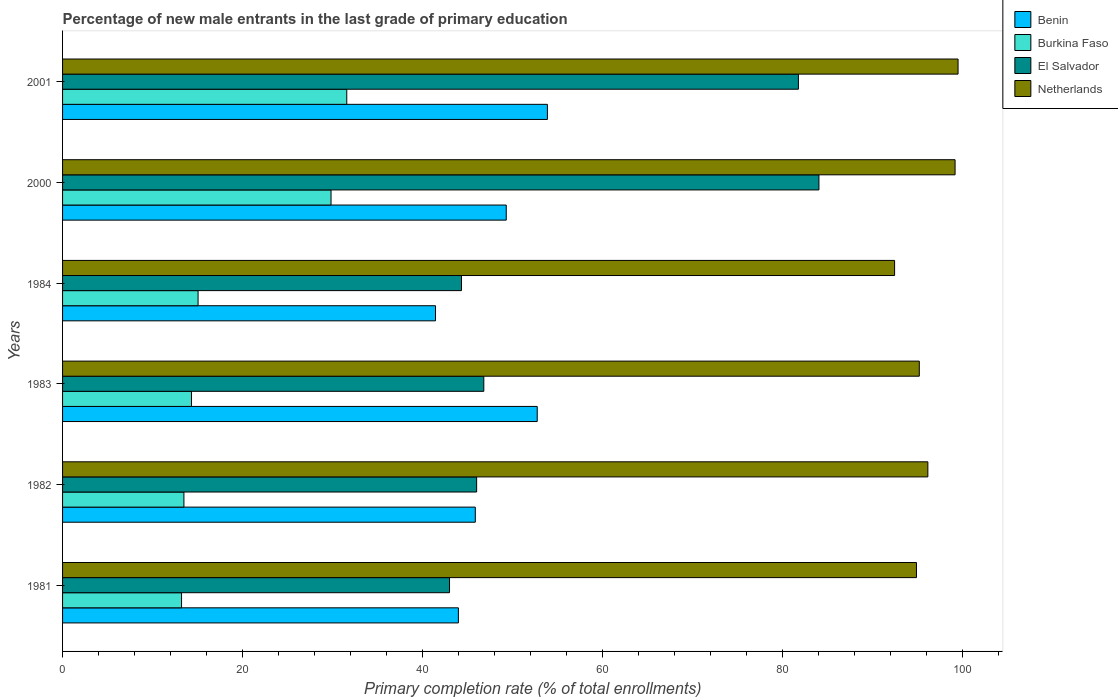How many different coloured bars are there?
Your answer should be compact. 4. How many groups of bars are there?
Offer a very short reply. 6. Are the number of bars per tick equal to the number of legend labels?
Your response must be concise. Yes. Are the number of bars on each tick of the Y-axis equal?
Your answer should be compact. Yes. How many bars are there on the 1st tick from the bottom?
Give a very brief answer. 4. In how many cases, is the number of bars for a given year not equal to the number of legend labels?
Your response must be concise. 0. What is the percentage of new male entrants in El Salvador in 1984?
Provide a short and direct response. 44.34. Across all years, what is the maximum percentage of new male entrants in Burkina Faso?
Provide a succinct answer. 31.59. Across all years, what is the minimum percentage of new male entrants in Netherlands?
Offer a very short reply. 92.48. In which year was the percentage of new male entrants in Netherlands maximum?
Ensure brevity in your answer.  2001. In which year was the percentage of new male entrants in El Salvador minimum?
Keep it short and to the point. 1981. What is the total percentage of new male entrants in Benin in the graph?
Your answer should be compact. 287.28. What is the difference between the percentage of new male entrants in Netherlands in 1983 and that in 2000?
Offer a very short reply. -3.98. What is the difference between the percentage of new male entrants in Benin in 1983 and the percentage of new male entrants in Burkina Faso in 1984?
Your answer should be very brief. 37.7. What is the average percentage of new male entrants in El Salvador per year?
Your answer should be compact. 57.67. In the year 1982, what is the difference between the percentage of new male entrants in El Salvador and percentage of new male entrants in Benin?
Offer a terse response. 0.15. What is the ratio of the percentage of new male entrants in Netherlands in 1984 to that in 2000?
Provide a short and direct response. 0.93. Is the percentage of new male entrants in El Salvador in 1984 less than that in 2000?
Offer a very short reply. Yes. What is the difference between the highest and the second highest percentage of new male entrants in Benin?
Offer a terse response. 1.13. What is the difference between the highest and the lowest percentage of new male entrants in Burkina Faso?
Provide a short and direct response. 18.36. Is it the case that in every year, the sum of the percentage of new male entrants in Netherlands and percentage of new male entrants in El Salvador is greater than the sum of percentage of new male entrants in Burkina Faso and percentage of new male entrants in Benin?
Offer a very short reply. Yes. What does the 2nd bar from the top in 2001 represents?
Your response must be concise. El Salvador. What does the 1st bar from the bottom in 1982 represents?
Your response must be concise. Benin. Is it the case that in every year, the sum of the percentage of new male entrants in El Salvador and percentage of new male entrants in Burkina Faso is greater than the percentage of new male entrants in Netherlands?
Provide a succinct answer. No. How many bars are there?
Make the answer very short. 24. How many years are there in the graph?
Your answer should be very brief. 6. What is the difference between two consecutive major ticks on the X-axis?
Keep it short and to the point. 20. Are the values on the major ticks of X-axis written in scientific E-notation?
Make the answer very short. No. How many legend labels are there?
Ensure brevity in your answer.  4. What is the title of the graph?
Your answer should be compact. Percentage of new male entrants in the last grade of primary education. What is the label or title of the X-axis?
Provide a succinct answer. Primary completion rate (% of total enrollments). What is the Primary completion rate (% of total enrollments) of Benin in 1981?
Your answer should be compact. 43.99. What is the Primary completion rate (% of total enrollments) in Burkina Faso in 1981?
Offer a terse response. 13.22. What is the Primary completion rate (% of total enrollments) of El Salvador in 1981?
Provide a succinct answer. 43.01. What is the Primary completion rate (% of total enrollments) of Netherlands in 1981?
Make the answer very short. 94.91. What is the Primary completion rate (% of total enrollments) of Benin in 1982?
Give a very brief answer. 45.87. What is the Primary completion rate (% of total enrollments) in Burkina Faso in 1982?
Make the answer very short. 13.49. What is the Primary completion rate (% of total enrollments) of El Salvador in 1982?
Ensure brevity in your answer.  46.02. What is the Primary completion rate (% of total enrollments) of Netherlands in 1982?
Give a very brief answer. 96.18. What is the Primary completion rate (% of total enrollments) in Benin in 1983?
Keep it short and to the point. 52.76. What is the Primary completion rate (% of total enrollments) of Burkina Faso in 1983?
Provide a succinct answer. 14.33. What is the Primary completion rate (% of total enrollments) of El Salvador in 1983?
Your response must be concise. 46.82. What is the Primary completion rate (% of total enrollments) in Netherlands in 1983?
Give a very brief answer. 95.22. What is the Primary completion rate (% of total enrollments) in Benin in 1984?
Your answer should be compact. 41.45. What is the Primary completion rate (% of total enrollments) in Burkina Faso in 1984?
Your response must be concise. 15.06. What is the Primary completion rate (% of total enrollments) in El Salvador in 1984?
Your answer should be compact. 44.34. What is the Primary completion rate (% of total enrollments) of Netherlands in 1984?
Your response must be concise. 92.48. What is the Primary completion rate (% of total enrollments) in Benin in 2000?
Offer a very short reply. 49.31. What is the Primary completion rate (% of total enrollments) in Burkina Faso in 2000?
Provide a short and direct response. 29.84. What is the Primary completion rate (% of total enrollments) of El Salvador in 2000?
Keep it short and to the point. 84.07. What is the Primary completion rate (% of total enrollments) in Netherlands in 2000?
Provide a succinct answer. 99.2. What is the Primary completion rate (% of total enrollments) of Benin in 2001?
Offer a terse response. 53.89. What is the Primary completion rate (% of total enrollments) in Burkina Faso in 2001?
Ensure brevity in your answer.  31.59. What is the Primary completion rate (% of total enrollments) in El Salvador in 2001?
Your answer should be compact. 81.79. What is the Primary completion rate (% of total enrollments) of Netherlands in 2001?
Offer a terse response. 99.53. Across all years, what is the maximum Primary completion rate (% of total enrollments) of Benin?
Give a very brief answer. 53.89. Across all years, what is the maximum Primary completion rate (% of total enrollments) in Burkina Faso?
Your response must be concise. 31.59. Across all years, what is the maximum Primary completion rate (% of total enrollments) in El Salvador?
Your answer should be very brief. 84.07. Across all years, what is the maximum Primary completion rate (% of total enrollments) of Netherlands?
Your answer should be very brief. 99.53. Across all years, what is the minimum Primary completion rate (% of total enrollments) of Benin?
Offer a very short reply. 41.45. Across all years, what is the minimum Primary completion rate (% of total enrollments) of Burkina Faso?
Offer a terse response. 13.22. Across all years, what is the minimum Primary completion rate (% of total enrollments) in El Salvador?
Keep it short and to the point. 43.01. Across all years, what is the minimum Primary completion rate (% of total enrollments) of Netherlands?
Offer a very short reply. 92.48. What is the total Primary completion rate (% of total enrollments) in Benin in the graph?
Offer a very short reply. 287.28. What is the total Primary completion rate (% of total enrollments) in Burkina Faso in the graph?
Make the answer very short. 117.53. What is the total Primary completion rate (% of total enrollments) in El Salvador in the graph?
Keep it short and to the point. 346.05. What is the total Primary completion rate (% of total enrollments) in Netherlands in the graph?
Your answer should be compact. 577.51. What is the difference between the Primary completion rate (% of total enrollments) in Benin in 1981 and that in 1982?
Provide a succinct answer. -1.88. What is the difference between the Primary completion rate (% of total enrollments) of Burkina Faso in 1981 and that in 1982?
Your answer should be very brief. -0.26. What is the difference between the Primary completion rate (% of total enrollments) in El Salvador in 1981 and that in 1982?
Give a very brief answer. -3.01. What is the difference between the Primary completion rate (% of total enrollments) in Netherlands in 1981 and that in 1982?
Your answer should be compact. -1.27. What is the difference between the Primary completion rate (% of total enrollments) in Benin in 1981 and that in 1983?
Provide a succinct answer. -8.76. What is the difference between the Primary completion rate (% of total enrollments) of Burkina Faso in 1981 and that in 1983?
Your response must be concise. -1.1. What is the difference between the Primary completion rate (% of total enrollments) of El Salvador in 1981 and that in 1983?
Offer a terse response. -3.81. What is the difference between the Primary completion rate (% of total enrollments) of Netherlands in 1981 and that in 1983?
Provide a succinct answer. -0.31. What is the difference between the Primary completion rate (% of total enrollments) in Benin in 1981 and that in 1984?
Offer a terse response. 2.54. What is the difference between the Primary completion rate (% of total enrollments) in Burkina Faso in 1981 and that in 1984?
Give a very brief answer. -1.84. What is the difference between the Primary completion rate (% of total enrollments) of El Salvador in 1981 and that in 1984?
Your answer should be compact. -1.33. What is the difference between the Primary completion rate (% of total enrollments) in Netherlands in 1981 and that in 1984?
Offer a very short reply. 2.43. What is the difference between the Primary completion rate (% of total enrollments) in Benin in 1981 and that in 2000?
Ensure brevity in your answer.  -5.32. What is the difference between the Primary completion rate (% of total enrollments) of Burkina Faso in 1981 and that in 2000?
Provide a succinct answer. -16.61. What is the difference between the Primary completion rate (% of total enrollments) of El Salvador in 1981 and that in 2000?
Provide a succinct answer. -41.06. What is the difference between the Primary completion rate (% of total enrollments) of Netherlands in 1981 and that in 2000?
Your answer should be very brief. -4.29. What is the difference between the Primary completion rate (% of total enrollments) of Benin in 1981 and that in 2001?
Provide a succinct answer. -9.89. What is the difference between the Primary completion rate (% of total enrollments) of Burkina Faso in 1981 and that in 2001?
Offer a terse response. -18.36. What is the difference between the Primary completion rate (% of total enrollments) of El Salvador in 1981 and that in 2001?
Ensure brevity in your answer.  -38.78. What is the difference between the Primary completion rate (% of total enrollments) in Netherlands in 1981 and that in 2001?
Ensure brevity in your answer.  -4.62. What is the difference between the Primary completion rate (% of total enrollments) of Benin in 1982 and that in 1983?
Keep it short and to the point. -6.88. What is the difference between the Primary completion rate (% of total enrollments) of Burkina Faso in 1982 and that in 1983?
Your answer should be very brief. -0.84. What is the difference between the Primary completion rate (% of total enrollments) in El Salvador in 1982 and that in 1983?
Keep it short and to the point. -0.8. What is the difference between the Primary completion rate (% of total enrollments) of Netherlands in 1982 and that in 1983?
Offer a very short reply. 0.95. What is the difference between the Primary completion rate (% of total enrollments) of Benin in 1982 and that in 1984?
Offer a terse response. 4.42. What is the difference between the Primary completion rate (% of total enrollments) of Burkina Faso in 1982 and that in 1984?
Provide a short and direct response. -1.57. What is the difference between the Primary completion rate (% of total enrollments) of El Salvador in 1982 and that in 1984?
Your response must be concise. 1.68. What is the difference between the Primary completion rate (% of total enrollments) of Netherlands in 1982 and that in 1984?
Offer a very short reply. 3.7. What is the difference between the Primary completion rate (% of total enrollments) of Benin in 1982 and that in 2000?
Your response must be concise. -3.44. What is the difference between the Primary completion rate (% of total enrollments) in Burkina Faso in 1982 and that in 2000?
Your response must be concise. -16.35. What is the difference between the Primary completion rate (% of total enrollments) in El Salvador in 1982 and that in 2000?
Offer a very short reply. -38.05. What is the difference between the Primary completion rate (% of total enrollments) of Netherlands in 1982 and that in 2000?
Provide a short and direct response. -3.02. What is the difference between the Primary completion rate (% of total enrollments) of Benin in 1982 and that in 2001?
Provide a short and direct response. -8.01. What is the difference between the Primary completion rate (% of total enrollments) in Burkina Faso in 1982 and that in 2001?
Ensure brevity in your answer.  -18.1. What is the difference between the Primary completion rate (% of total enrollments) of El Salvador in 1982 and that in 2001?
Your response must be concise. -35.76. What is the difference between the Primary completion rate (% of total enrollments) in Netherlands in 1982 and that in 2001?
Offer a very short reply. -3.36. What is the difference between the Primary completion rate (% of total enrollments) of Benin in 1983 and that in 1984?
Give a very brief answer. 11.31. What is the difference between the Primary completion rate (% of total enrollments) of Burkina Faso in 1983 and that in 1984?
Your answer should be compact. -0.73. What is the difference between the Primary completion rate (% of total enrollments) in El Salvador in 1983 and that in 1984?
Offer a terse response. 2.48. What is the difference between the Primary completion rate (% of total enrollments) of Netherlands in 1983 and that in 1984?
Provide a succinct answer. 2.75. What is the difference between the Primary completion rate (% of total enrollments) of Benin in 1983 and that in 2000?
Provide a succinct answer. 3.44. What is the difference between the Primary completion rate (% of total enrollments) in Burkina Faso in 1983 and that in 2000?
Offer a very short reply. -15.51. What is the difference between the Primary completion rate (% of total enrollments) of El Salvador in 1983 and that in 2000?
Ensure brevity in your answer.  -37.25. What is the difference between the Primary completion rate (% of total enrollments) in Netherlands in 1983 and that in 2000?
Your response must be concise. -3.98. What is the difference between the Primary completion rate (% of total enrollments) of Benin in 1983 and that in 2001?
Your answer should be compact. -1.13. What is the difference between the Primary completion rate (% of total enrollments) of Burkina Faso in 1983 and that in 2001?
Your response must be concise. -17.26. What is the difference between the Primary completion rate (% of total enrollments) in El Salvador in 1983 and that in 2001?
Ensure brevity in your answer.  -34.96. What is the difference between the Primary completion rate (% of total enrollments) of Netherlands in 1983 and that in 2001?
Offer a terse response. -4.31. What is the difference between the Primary completion rate (% of total enrollments) of Benin in 1984 and that in 2000?
Offer a terse response. -7.86. What is the difference between the Primary completion rate (% of total enrollments) of Burkina Faso in 1984 and that in 2000?
Provide a succinct answer. -14.78. What is the difference between the Primary completion rate (% of total enrollments) of El Salvador in 1984 and that in 2000?
Offer a very short reply. -39.73. What is the difference between the Primary completion rate (% of total enrollments) of Netherlands in 1984 and that in 2000?
Your answer should be very brief. -6.72. What is the difference between the Primary completion rate (% of total enrollments) in Benin in 1984 and that in 2001?
Offer a terse response. -12.44. What is the difference between the Primary completion rate (% of total enrollments) of Burkina Faso in 1984 and that in 2001?
Offer a very short reply. -16.53. What is the difference between the Primary completion rate (% of total enrollments) in El Salvador in 1984 and that in 2001?
Make the answer very short. -37.44. What is the difference between the Primary completion rate (% of total enrollments) of Netherlands in 1984 and that in 2001?
Offer a terse response. -7.05. What is the difference between the Primary completion rate (% of total enrollments) of Benin in 2000 and that in 2001?
Offer a very short reply. -4.57. What is the difference between the Primary completion rate (% of total enrollments) of Burkina Faso in 2000 and that in 2001?
Offer a terse response. -1.75. What is the difference between the Primary completion rate (% of total enrollments) of El Salvador in 2000 and that in 2001?
Keep it short and to the point. 2.28. What is the difference between the Primary completion rate (% of total enrollments) of Netherlands in 2000 and that in 2001?
Your answer should be very brief. -0.33. What is the difference between the Primary completion rate (% of total enrollments) of Benin in 1981 and the Primary completion rate (% of total enrollments) of Burkina Faso in 1982?
Your answer should be very brief. 30.51. What is the difference between the Primary completion rate (% of total enrollments) of Benin in 1981 and the Primary completion rate (% of total enrollments) of El Salvador in 1982?
Ensure brevity in your answer.  -2.03. What is the difference between the Primary completion rate (% of total enrollments) of Benin in 1981 and the Primary completion rate (% of total enrollments) of Netherlands in 1982?
Provide a succinct answer. -52.18. What is the difference between the Primary completion rate (% of total enrollments) in Burkina Faso in 1981 and the Primary completion rate (% of total enrollments) in El Salvador in 1982?
Your answer should be compact. -32.8. What is the difference between the Primary completion rate (% of total enrollments) of Burkina Faso in 1981 and the Primary completion rate (% of total enrollments) of Netherlands in 1982?
Make the answer very short. -82.95. What is the difference between the Primary completion rate (% of total enrollments) of El Salvador in 1981 and the Primary completion rate (% of total enrollments) of Netherlands in 1982?
Provide a short and direct response. -53.17. What is the difference between the Primary completion rate (% of total enrollments) of Benin in 1981 and the Primary completion rate (% of total enrollments) of Burkina Faso in 1983?
Offer a terse response. 29.67. What is the difference between the Primary completion rate (% of total enrollments) of Benin in 1981 and the Primary completion rate (% of total enrollments) of El Salvador in 1983?
Ensure brevity in your answer.  -2.83. What is the difference between the Primary completion rate (% of total enrollments) of Benin in 1981 and the Primary completion rate (% of total enrollments) of Netherlands in 1983?
Give a very brief answer. -51.23. What is the difference between the Primary completion rate (% of total enrollments) in Burkina Faso in 1981 and the Primary completion rate (% of total enrollments) in El Salvador in 1983?
Provide a succinct answer. -33.6. What is the difference between the Primary completion rate (% of total enrollments) in Burkina Faso in 1981 and the Primary completion rate (% of total enrollments) in Netherlands in 1983?
Keep it short and to the point. -82. What is the difference between the Primary completion rate (% of total enrollments) in El Salvador in 1981 and the Primary completion rate (% of total enrollments) in Netherlands in 1983?
Give a very brief answer. -52.21. What is the difference between the Primary completion rate (% of total enrollments) in Benin in 1981 and the Primary completion rate (% of total enrollments) in Burkina Faso in 1984?
Offer a terse response. 28.93. What is the difference between the Primary completion rate (% of total enrollments) in Benin in 1981 and the Primary completion rate (% of total enrollments) in El Salvador in 1984?
Offer a very short reply. -0.35. What is the difference between the Primary completion rate (% of total enrollments) in Benin in 1981 and the Primary completion rate (% of total enrollments) in Netherlands in 1984?
Offer a terse response. -48.48. What is the difference between the Primary completion rate (% of total enrollments) in Burkina Faso in 1981 and the Primary completion rate (% of total enrollments) in El Salvador in 1984?
Offer a terse response. -31.12. What is the difference between the Primary completion rate (% of total enrollments) of Burkina Faso in 1981 and the Primary completion rate (% of total enrollments) of Netherlands in 1984?
Keep it short and to the point. -79.25. What is the difference between the Primary completion rate (% of total enrollments) of El Salvador in 1981 and the Primary completion rate (% of total enrollments) of Netherlands in 1984?
Offer a terse response. -49.47. What is the difference between the Primary completion rate (% of total enrollments) in Benin in 1981 and the Primary completion rate (% of total enrollments) in Burkina Faso in 2000?
Keep it short and to the point. 14.16. What is the difference between the Primary completion rate (% of total enrollments) of Benin in 1981 and the Primary completion rate (% of total enrollments) of El Salvador in 2000?
Your answer should be very brief. -40.07. What is the difference between the Primary completion rate (% of total enrollments) of Benin in 1981 and the Primary completion rate (% of total enrollments) of Netherlands in 2000?
Ensure brevity in your answer.  -55.21. What is the difference between the Primary completion rate (% of total enrollments) of Burkina Faso in 1981 and the Primary completion rate (% of total enrollments) of El Salvador in 2000?
Offer a terse response. -70.84. What is the difference between the Primary completion rate (% of total enrollments) in Burkina Faso in 1981 and the Primary completion rate (% of total enrollments) in Netherlands in 2000?
Your answer should be compact. -85.97. What is the difference between the Primary completion rate (% of total enrollments) of El Salvador in 1981 and the Primary completion rate (% of total enrollments) of Netherlands in 2000?
Provide a succinct answer. -56.19. What is the difference between the Primary completion rate (% of total enrollments) of Benin in 1981 and the Primary completion rate (% of total enrollments) of Burkina Faso in 2001?
Provide a short and direct response. 12.41. What is the difference between the Primary completion rate (% of total enrollments) in Benin in 1981 and the Primary completion rate (% of total enrollments) in El Salvador in 2001?
Your answer should be compact. -37.79. What is the difference between the Primary completion rate (% of total enrollments) of Benin in 1981 and the Primary completion rate (% of total enrollments) of Netherlands in 2001?
Provide a succinct answer. -55.54. What is the difference between the Primary completion rate (% of total enrollments) of Burkina Faso in 1981 and the Primary completion rate (% of total enrollments) of El Salvador in 2001?
Provide a short and direct response. -68.56. What is the difference between the Primary completion rate (% of total enrollments) in Burkina Faso in 1981 and the Primary completion rate (% of total enrollments) in Netherlands in 2001?
Make the answer very short. -86.31. What is the difference between the Primary completion rate (% of total enrollments) of El Salvador in 1981 and the Primary completion rate (% of total enrollments) of Netherlands in 2001?
Provide a succinct answer. -56.52. What is the difference between the Primary completion rate (% of total enrollments) of Benin in 1982 and the Primary completion rate (% of total enrollments) of Burkina Faso in 1983?
Give a very brief answer. 31.55. What is the difference between the Primary completion rate (% of total enrollments) in Benin in 1982 and the Primary completion rate (% of total enrollments) in El Salvador in 1983?
Keep it short and to the point. -0.95. What is the difference between the Primary completion rate (% of total enrollments) of Benin in 1982 and the Primary completion rate (% of total enrollments) of Netherlands in 1983?
Provide a short and direct response. -49.35. What is the difference between the Primary completion rate (% of total enrollments) of Burkina Faso in 1982 and the Primary completion rate (% of total enrollments) of El Salvador in 1983?
Ensure brevity in your answer.  -33.33. What is the difference between the Primary completion rate (% of total enrollments) of Burkina Faso in 1982 and the Primary completion rate (% of total enrollments) of Netherlands in 1983?
Offer a very short reply. -81.73. What is the difference between the Primary completion rate (% of total enrollments) of El Salvador in 1982 and the Primary completion rate (% of total enrollments) of Netherlands in 1983?
Provide a succinct answer. -49.2. What is the difference between the Primary completion rate (% of total enrollments) of Benin in 1982 and the Primary completion rate (% of total enrollments) of Burkina Faso in 1984?
Give a very brief answer. 30.81. What is the difference between the Primary completion rate (% of total enrollments) of Benin in 1982 and the Primary completion rate (% of total enrollments) of El Salvador in 1984?
Your answer should be compact. 1.53. What is the difference between the Primary completion rate (% of total enrollments) in Benin in 1982 and the Primary completion rate (% of total enrollments) in Netherlands in 1984?
Offer a very short reply. -46.6. What is the difference between the Primary completion rate (% of total enrollments) of Burkina Faso in 1982 and the Primary completion rate (% of total enrollments) of El Salvador in 1984?
Your answer should be very brief. -30.85. What is the difference between the Primary completion rate (% of total enrollments) of Burkina Faso in 1982 and the Primary completion rate (% of total enrollments) of Netherlands in 1984?
Your response must be concise. -78.99. What is the difference between the Primary completion rate (% of total enrollments) in El Salvador in 1982 and the Primary completion rate (% of total enrollments) in Netherlands in 1984?
Make the answer very short. -46.45. What is the difference between the Primary completion rate (% of total enrollments) of Benin in 1982 and the Primary completion rate (% of total enrollments) of Burkina Faso in 2000?
Provide a short and direct response. 16.03. What is the difference between the Primary completion rate (% of total enrollments) in Benin in 1982 and the Primary completion rate (% of total enrollments) in El Salvador in 2000?
Give a very brief answer. -38.19. What is the difference between the Primary completion rate (% of total enrollments) in Benin in 1982 and the Primary completion rate (% of total enrollments) in Netherlands in 2000?
Make the answer very short. -53.33. What is the difference between the Primary completion rate (% of total enrollments) in Burkina Faso in 1982 and the Primary completion rate (% of total enrollments) in El Salvador in 2000?
Ensure brevity in your answer.  -70.58. What is the difference between the Primary completion rate (% of total enrollments) of Burkina Faso in 1982 and the Primary completion rate (% of total enrollments) of Netherlands in 2000?
Keep it short and to the point. -85.71. What is the difference between the Primary completion rate (% of total enrollments) of El Salvador in 1982 and the Primary completion rate (% of total enrollments) of Netherlands in 2000?
Offer a very short reply. -53.18. What is the difference between the Primary completion rate (% of total enrollments) of Benin in 1982 and the Primary completion rate (% of total enrollments) of Burkina Faso in 2001?
Your response must be concise. 14.28. What is the difference between the Primary completion rate (% of total enrollments) in Benin in 1982 and the Primary completion rate (% of total enrollments) in El Salvador in 2001?
Provide a succinct answer. -35.91. What is the difference between the Primary completion rate (% of total enrollments) in Benin in 1982 and the Primary completion rate (% of total enrollments) in Netherlands in 2001?
Offer a terse response. -53.66. What is the difference between the Primary completion rate (% of total enrollments) in Burkina Faso in 1982 and the Primary completion rate (% of total enrollments) in El Salvador in 2001?
Give a very brief answer. -68.3. What is the difference between the Primary completion rate (% of total enrollments) in Burkina Faso in 1982 and the Primary completion rate (% of total enrollments) in Netherlands in 2001?
Your answer should be very brief. -86.04. What is the difference between the Primary completion rate (% of total enrollments) in El Salvador in 1982 and the Primary completion rate (% of total enrollments) in Netherlands in 2001?
Your answer should be compact. -53.51. What is the difference between the Primary completion rate (% of total enrollments) of Benin in 1983 and the Primary completion rate (% of total enrollments) of Burkina Faso in 1984?
Your answer should be compact. 37.7. What is the difference between the Primary completion rate (% of total enrollments) in Benin in 1983 and the Primary completion rate (% of total enrollments) in El Salvador in 1984?
Keep it short and to the point. 8.42. What is the difference between the Primary completion rate (% of total enrollments) in Benin in 1983 and the Primary completion rate (% of total enrollments) in Netherlands in 1984?
Offer a terse response. -39.72. What is the difference between the Primary completion rate (% of total enrollments) of Burkina Faso in 1983 and the Primary completion rate (% of total enrollments) of El Salvador in 1984?
Keep it short and to the point. -30.01. What is the difference between the Primary completion rate (% of total enrollments) in Burkina Faso in 1983 and the Primary completion rate (% of total enrollments) in Netherlands in 1984?
Offer a terse response. -78.15. What is the difference between the Primary completion rate (% of total enrollments) of El Salvador in 1983 and the Primary completion rate (% of total enrollments) of Netherlands in 1984?
Make the answer very short. -45.66. What is the difference between the Primary completion rate (% of total enrollments) in Benin in 1983 and the Primary completion rate (% of total enrollments) in Burkina Faso in 2000?
Keep it short and to the point. 22.92. What is the difference between the Primary completion rate (% of total enrollments) of Benin in 1983 and the Primary completion rate (% of total enrollments) of El Salvador in 2000?
Make the answer very short. -31.31. What is the difference between the Primary completion rate (% of total enrollments) of Benin in 1983 and the Primary completion rate (% of total enrollments) of Netherlands in 2000?
Make the answer very short. -46.44. What is the difference between the Primary completion rate (% of total enrollments) in Burkina Faso in 1983 and the Primary completion rate (% of total enrollments) in El Salvador in 2000?
Your response must be concise. -69.74. What is the difference between the Primary completion rate (% of total enrollments) in Burkina Faso in 1983 and the Primary completion rate (% of total enrollments) in Netherlands in 2000?
Make the answer very short. -84.87. What is the difference between the Primary completion rate (% of total enrollments) of El Salvador in 1983 and the Primary completion rate (% of total enrollments) of Netherlands in 2000?
Ensure brevity in your answer.  -52.38. What is the difference between the Primary completion rate (% of total enrollments) of Benin in 1983 and the Primary completion rate (% of total enrollments) of Burkina Faso in 2001?
Provide a short and direct response. 21.17. What is the difference between the Primary completion rate (% of total enrollments) of Benin in 1983 and the Primary completion rate (% of total enrollments) of El Salvador in 2001?
Make the answer very short. -29.03. What is the difference between the Primary completion rate (% of total enrollments) in Benin in 1983 and the Primary completion rate (% of total enrollments) in Netherlands in 2001?
Ensure brevity in your answer.  -46.77. What is the difference between the Primary completion rate (% of total enrollments) in Burkina Faso in 1983 and the Primary completion rate (% of total enrollments) in El Salvador in 2001?
Keep it short and to the point. -67.46. What is the difference between the Primary completion rate (% of total enrollments) in Burkina Faso in 1983 and the Primary completion rate (% of total enrollments) in Netherlands in 2001?
Ensure brevity in your answer.  -85.2. What is the difference between the Primary completion rate (% of total enrollments) of El Salvador in 1983 and the Primary completion rate (% of total enrollments) of Netherlands in 2001?
Give a very brief answer. -52.71. What is the difference between the Primary completion rate (% of total enrollments) of Benin in 1984 and the Primary completion rate (% of total enrollments) of Burkina Faso in 2000?
Your answer should be compact. 11.61. What is the difference between the Primary completion rate (% of total enrollments) of Benin in 1984 and the Primary completion rate (% of total enrollments) of El Salvador in 2000?
Offer a terse response. -42.62. What is the difference between the Primary completion rate (% of total enrollments) in Benin in 1984 and the Primary completion rate (% of total enrollments) in Netherlands in 2000?
Your answer should be very brief. -57.75. What is the difference between the Primary completion rate (% of total enrollments) in Burkina Faso in 1984 and the Primary completion rate (% of total enrollments) in El Salvador in 2000?
Your response must be concise. -69.01. What is the difference between the Primary completion rate (% of total enrollments) of Burkina Faso in 1984 and the Primary completion rate (% of total enrollments) of Netherlands in 2000?
Your answer should be very brief. -84.14. What is the difference between the Primary completion rate (% of total enrollments) in El Salvador in 1984 and the Primary completion rate (% of total enrollments) in Netherlands in 2000?
Offer a very short reply. -54.86. What is the difference between the Primary completion rate (% of total enrollments) in Benin in 1984 and the Primary completion rate (% of total enrollments) in Burkina Faso in 2001?
Keep it short and to the point. 9.86. What is the difference between the Primary completion rate (% of total enrollments) of Benin in 1984 and the Primary completion rate (% of total enrollments) of El Salvador in 2001?
Give a very brief answer. -40.33. What is the difference between the Primary completion rate (% of total enrollments) of Benin in 1984 and the Primary completion rate (% of total enrollments) of Netherlands in 2001?
Offer a terse response. -58.08. What is the difference between the Primary completion rate (% of total enrollments) of Burkina Faso in 1984 and the Primary completion rate (% of total enrollments) of El Salvador in 2001?
Provide a short and direct response. -66.72. What is the difference between the Primary completion rate (% of total enrollments) of Burkina Faso in 1984 and the Primary completion rate (% of total enrollments) of Netherlands in 2001?
Provide a succinct answer. -84.47. What is the difference between the Primary completion rate (% of total enrollments) in El Salvador in 1984 and the Primary completion rate (% of total enrollments) in Netherlands in 2001?
Provide a short and direct response. -55.19. What is the difference between the Primary completion rate (% of total enrollments) of Benin in 2000 and the Primary completion rate (% of total enrollments) of Burkina Faso in 2001?
Provide a succinct answer. 17.73. What is the difference between the Primary completion rate (% of total enrollments) in Benin in 2000 and the Primary completion rate (% of total enrollments) in El Salvador in 2001?
Your answer should be very brief. -32.47. What is the difference between the Primary completion rate (% of total enrollments) in Benin in 2000 and the Primary completion rate (% of total enrollments) in Netherlands in 2001?
Ensure brevity in your answer.  -50.22. What is the difference between the Primary completion rate (% of total enrollments) of Burkina Faso in 2000 and the Primary completion rate (% of total enrollments) of El Salvador in 2001?
Keep it short and to the point. -51.95. What is the difference between the Primary completion rate (% of total enrollments) of Burkina Faso in 2000 and the Primary completion rate (% of total enrollments) of Netherlands in 2001?
Ensure brevity in your answer.  -69.69. What is the difference between the Primary completion rate (% of total enrollments) of El Salvador in 2000 and the Primary completion rate (% of total enrollments) of Netherlands in 2001?
Give a very brief answer. -15.46. What is the average Primary completion rate (% of total enrollments) of Benin per year?
Provide a short and direct response. 47.88. What is the average Primary completion rate (% of total enrollments) in Burkina Faso per year?
Keep it short and to the point. 19.59. What is the average Primary completion rate (% of total enrollments) in El Salvador per year?
Make the answer very short. 57.67. What is the average Primary completion rate (% of total enrollments) of Netherlands per year?
Your answer should be very brief. 96.25. In the year 1981, what is the difference between the Primary completion rate (% of total enrollments) of Benin and Primary completion rate (% of total enrollments) of Burkina Faso?
Your answer should be compact. 30.77. In the year 1981, what is the difference between the Primary completion rate (% of total enrollments) of Benin and Primary completion rate (% of total enrollments) of El Salvador?
Offer a very short reply. 0.98. In the year 1981, what is the difference between the Primary completion rate (% of total enrollments) of Benin and Primary completion rate (% of total enrollments) of Netherlands?
Offer a terse response. -50.91. In the year 1981, what is the difference between the Primary completion rate (% of total enrollments) in Burkina Faso and Primary completion rate (% of total enrollments) in El Salvador?
Offer a terse response. -29.79. In the year 1981, what is the difference between the Primary completion rate (% of total enrollments) in Burkina Faso and Primary completion rate (% of total enrollments) in Netherlands?
Offer a very short reply. -81.68. In the year 1981, what is the difference between the Primary completion rate (% of total enrollments) of El Salvador and Primary completion rate (% of total enrollments) of Netherlands?
Ensure brevity in your answer.  -51.9. In the year 1982, what is the difference between the Primary completion rate (% of total enrollments) in Benin and Primary completion rate (% of total enrollments) in Burkina Faso?
Offer a terse response. 32.38. In the year 1982, what is the difference between the Primary completion rate (% of total enrollments) in Benin and Primary completion rate (% of total enrollments) in El Salvador?
Give a very brief answer. -0.15. In the year 1982, what is the difference between the Primary completion rate (% of total enrollments) in Benin and Primary completion rate (% of total enrollments) in Netherlands?
Make the answer very short. -50.3. In the year 1982, what is the difference between the Primary completion rate (% of total enrollments) of Burkina Faso and Primary completion rate (% of total enrollments) of El Salvador?
Provide a succinct answer. -32.53. In the year 1982, what is the difference between the Primary completion rate (% of total enrollments) in Burkina Faso and Primary completion rate (% of total enrollments) in Netherlands?
Provide a short and direct response. -82.69. In the year 1982, what is the difference between the Primary completion rate (% of total enrollments) of El Salvador and Primary completion rate (% of total enrollments) of Netherlands?
Provide a short and direct response. -50.15. In the year 1983, what is the difference between the Primary completion rate (% of total enrollments) of Benin and Primary completion rate (% of total enrollments) of Burkina Faso?
Offer a terse response. 38.43. In the year 1983, what is the difference between the Primary completion rate (% of total enrollments) in Benin and Primary completion rate (% of total enrollments) in El Salvador?
Give a very brief answer. 5.94. In the year 1983, what is the difference between the Primary completion rate (% of total enrollments) of Benin and Primary completion rate (% of total enrollments) of Netherlands?
Offer a terse response. -42.47. In the year 1983, what is the difference between the Primary completion rate (% of total enrollments) of Burkina Faso and Primary completion rate (% of total enrollments) of El Salvador?
Make the answer very short. -32.49. In the year 1983, what is the difference between the Primary completion rate (% of total enrollments) in Burkina Faso and Primary completion rate (% of total enrollments) in Netherlands?
Your response must be concise. -80.9. In the year 1983, what is the difference between the Primary completion rate (% of total enrollments) in El Salvador and Primary completion rate (% of total enrollments) in Netherlands?
Provide a succinct answer. -48.4. In the year 1984, what is the difference between the Primary completion rate (% of total enrollments) in Benin and Primary completion rate (% of total enrollments) in Burkina Faso?
Make the answer very short. 26.39. In the year 1984, what is the difference between the Primary completion rate (% of total enrollments) in Benin and Primary completion rate (% of total enrollments) in El Salvador?
Offer a terse response. -2.89. In the year 1984, what is the difference between the Primary completion rate (% of total enrollments) of Benin and Primary completion rate (% of total enrollments) of Netherlands?
Provide a short and direct response. -51.03. In the year 1984, what is the difference between the Primary completion rate (% of total enrollments) of Burkina Faso and Primary completion rate (% of total enrollments) of El Salvador?
Keep it short and to the point. -29.28. In the year 1984, what is the difference between the Primary completion rate (% of total enrollments) in Burkina Faso and Primary completion rate (% of total enrollments) in Netherlands?
Keep it short and to the point. -77.42. In the year 1984, what is the difference between the Primary completion rate (% of total enrollments) in El Salvador and Primary completion rate (% of total enrollments) in Netherlands?
Ensure brevity in your answer.  -48.14. In the year 2000, what is the difference between the Primary completion rate (% of total enrollments) in Benin and Primary completion rate (% of total enrollments) in Burkina Faso?
Keep it short and to the point. 19.48. In the year 2000, what is the difference between the Primary completion rate (% of total enrollments) of Benin and Primary completion rate (% of total enrollments) of El Salvador?
Provide a short and direct response. -34.75. In the year 2000, what is the difference between the Primary completion rate (% of total enrollments) in Benin and Primary completion rate (% of total enrollments) in Netherlands?
Provide a short and direct response. -49.89. In the year 2000, what is the difference between the Primary completion rate (% of total enrollments) of Burkina Faso and Primary completion rate (% of total enrollments) of El Salvador?
Provide a succinct answer. -54.23. In the year 2000, what is the difference between the Primary completion rate (% of total enrollments) in Burkina Faso and Primary completion rate (% of total enrollments) in Netherlands?
Provide a succinct answer. -69.36. In the year 2000, what is the difference between the Primary completion rate (% of total enrollments) of El Salvador and Primary completion rate (% of total enrollments) of Netherlands?
Ensure brevity in your answer.  -15.13. In the year 2001, what is the difference between the Primary completion rate (% of total enrollments) in Benin and Primary completion rate (% of total enrollments) in Burkina Faso?
Provide a short and direct response. 22.3. In the year 2001, what is the difference between the Primary completion rate (% of total enrollments) in Benin and Primary completion rate (% of total enrollments) in El Salvador?
Give a very brief answer. -27.9. In the year 2001, what is the difference between the Primary completion rate (% of total enrollments) of Benin and Primary completion rate (% of total enrollments) of Netherlands?
Offer a terse response. -45.64. In the year 2001, what is the difference between the Primary completion rate (% of total enrollments) in Burkina Faso and Primary completion rate (% of total enrollments) in El Salvador?
Ensure brevity in your answer.  -50.2. In the year 2001, what is the difference between the Primary completion rate (% of total enrollments) of Burkina Faso and Primary completion rate (% of total enrollments) of Netherlands?
Offer a very short reply. -67.94. In the year 2001, what is the difference between the Primary completion rate (% of total enrollments) in El Salvador and Primary completion rate (% of total enrollments) in Netherlands?
Provide a short and direct response. -17.75. What is the ratio of the Primary completion rate (% of total enrollments) in Burkina Faso in 1981 to that in 1982?
Give a very brief answer. 0.98. What is the ratio of the Primary completion rate (% of total enrollments) in El Salvador in 1981 to that in 1982?
Give a very brief answer. 0.93. What is the ratio of the Primary completion rate (% of total enrollments) in Netherlands in 1981 to that in 1982?
Provide a short and direct response. 0.99. What is the ratio of the Primary completion rate (% of total enrollments) in Benin in 1981 to that in 1983?
Make the answer very short. 0.83. What is the ratio of the Primary completion rate (% of total enrollments) of Burkina Faso in 1981 to that in 1983?
Provide a succinct answer. 0.92. What is the ratio of the Primary completion rate (% of total enrollments) in El Salvador in 1981 to that in 1983?
Your answer should be compact. 0.92. What is the ratio of the Primary completion rate (% of total enrollments) of Netherlands in 1981 to that in 1983?
Your response must be concise. 1. What is the ratio of the Primary completion rate (% of total enrollments) in Benin in 1981 to that in 1984?
Your response must be concise. 1.06. What is the ratio of the Primary completion rate (% of total enrollments) of Burkina Faso in 1981 to that in 1984?
Provide a succinct answer. 0.88. What is the ratio of the Primary completion rate (% of total enrollments) in El Salvador in 1981 to that in 1984?
Offer a terse response. 0.97. What is the ratio of the Primary completion rate (% of total enrollments) of Netherlands in 1981 to that in 1984?
Make the answer very short. 1.03. What is the ratio of the Primary completion rate (% of total enrollments) in Benin in 1981 to that in 2000?
Keep it short and to the point. 0.89. What is the ratio of the Primary completion rate (% of total enrollments) of Burkina Faso in 1981 to that in 2000?
Offer a terse response. 0.44. What is the ratio of the Primary completion rate (% of total enrollments) in El Salvador in 1981 to that in 2000?
Offer a very short reply. 0.51. What is the ratio of the Primary completion rate (% of total enrollments) of Netherlands in 1981 to that in 2000?
Offer a terse response. 0.96. What is the ratio of the Primary completion rate (% of total enrollments) of Benin in 1981 to that in 2001?
Your answer should be compact. 0.82. What is the ratio of the Primary completion rate (% of total enrollments) of Burkina Faso in 1981 to that in 2001?
Your answer should be very brief. 0.42. What is the ratio of the Primary completion rate (% of total enrollments) in El Salvador in 1981 to that in 2001?
Make the answer very short. 0.53. What is the ratio of the Primary completion rate (% of total enrollments) in Netherlands in 1981 to that in 2001?
Provide a succinct answer. 0.95. What is the ratio of the Primary completion rate (% of total enrollments) in Benin in 1982 to that in 1983?
Keep it short and to the point. 0.87. What is the ratio of the Primary completion rate (% of total enrollments) of Burkina Faso in 1982 to that in 1983?
Your answer should be compact. 0.94. What is the ratio of the Primary completion rate (% of total enrollments) in El Salvador in 1982 to that in 1983?
Offer a terse response. 0.98. What is the ratio of the Primary completion rate (% of total enrollments) in Benin in 1982 to that in 1984?
Give a very brief answer. 1.11. What is the ratio of the Primary completion rate (% of total enrollments) in Burkina Faso in 1982 to that in 1984?
Give a very brief answer. 0.9. What is the ratio of the Primary completion rate (% of total enrollments) in El Salvador in 1982 to that in 1984?
Ensure brevity in your answer.  1.04. What is the ratio of the Primary completion rate (% of total enrollments) in Netherlands in 1982 to that in 1984?
Keep it short and to the point. 1.04. What is the ratio of the Primary completion rate (% of total enrollments) in Benin in 1982 to that in 2000?
Offer a terse response. 0.93. What is the ratio of the Primary completion rate (% of total enrollments) of Burkina Faso in 1982 to that in 2000?
Offer a terse response. 0.45. What is the ratio of the Primary completion rate (% of total enrollments) of El Salvador in 1982 to that in 2000?
Keep it short and to the point. 0.55. What is the ratio of the Primary completion rate (% of total enrollments) in Netherlands in 1982 to that in 2000?
Provide a succinct answer. 0.97. What is the ratio of the Primary completion rate (% of total enrollments) in Benin in 1982 to that in 2001?
Provide a succinct answer. 0.85. What is the ratio of the Primary completion rate (% of total enrollments) of Burkina Faso in 1982 to that in 2001?
Your answer should be compact. 0.43. What is the ratio of the Primary completion rate (% of total enrollments) of El Salvador in 1982 to that in 2001?
Make the answer very short. 0.56. What is the ratio of the Primary completion rate (% of total enrollments) of Netherlands in 1982 to that in 2001?
Make the answer very short. 0.97. What is the ratio of the Primary completion rate (% of total enrollments) in Benin in 1983 to that in 1984?
Give a very brief answer. 1.27. What is the ratio of the Primary completion rate (% of total enrollments) in Burkina Faso in 1983 to that in 1984?
Your response must be concise. 0.95. What is the ratio of the Primary completion rate (% of total enrollments) of El Salvador in 1983 to that in 1984?
Provide a succinct answer. 1.06. What is the ratio of the Primary completion rate (% of total enrollments) of Netherlands in 1983 to that in 1984?
Provide a short and direct response. 1.03. What is the ratio of the Primary completion rate (% of total enrollments) of Benin in 1983 to that in 2000?
Make the answer very short. 1.07. What is the ratio of the Primary completion rate (% of total enrollments) in Burkina Faso in 1983 to that in 2000?
Keep it short and to the point. 0.48. What is the ratio of the Primary completion rate (% of total enrollments) in El Salvador in 1983 to that in 2000?
Offer a terse response. 0.56. What is the ratio of the Primary completion rate (% of total enrollments) in Netherlands in 1983 to that in 2000?
Ensure brevity in your answer.  0.96. What is the ratio of the Primary completion rate (% of total enrollments) in Burkina Faso in 1983 to that in 2001?
Give a very brief answer. 0.45. What is the ratio of the Primary completion rate (% of total enrollments) in El Salvador in 1983 to that in 2001?
Make the answer very short. 0.57. What is the ratio of the Primary completion rate (% of total enrollments) of Netherlands in 1983 to that in 2001?
Offer a terse response. 0.96. What is the ratio of the Primary completion rate (% of total enrollments) of Benin in 1984 to that in 2000?
Keep it short and to the point. 0.84. What is the ratio of the Primary completion rate (% of total enrollments) of Burkina Faso in 1984 to that in 2000?
Provide a short and direct response. 0.5. What is the ratio of the Primary completion rate (% of total enrollments) of El Salvador in 1984 to that in 2000?
Your answer should be compact. 0.53. What is the ratio of the Primary completion rate (% of total enrollments) of Netherlands in 1984 to that in 2000?
Your answer should be very brief. 0.93. What is the ratio of the Primary completion rate (% of total enrollments) of Benin in 1984 to that in 2001?
Ensure brevity in your answer.  0.77. What is the ratio of the Primary completion rate (% of total enrollments) of Burkina Faso in 1984 to that in 2001?
Your response must be concise. 0.48. What is the ratio of the Primary completion rate (% of total enrollments) of El Salvador in 1984 to that in 2001?
Provide a short and direct response. 0.54. What is the ratio of the Primary completion rate (% of total enrollments) of Netherlands in 1984 to that in 2001?
Offer a terse response. 0.93. What is the ratio of the Primary completion rate (% of total enrollments) of Benin in 2000 to that in 2001?
Provide a succinct answer. 0.92. What is the ratio of the Primary completion rate (% of total enrollments) of Burkina Faso in 2000 to that in 2001?
Ensure brevity in your answer.  0.94. What is the ratio of the Primary completion rate (% of total enrollments) of El Salvador in 2000 to that in 2001?
Make the answer very short. 1.03. What is the ratio of the Primary completion rate (% of total enrollments) in Netherlands in 2000 to that in 2001?
Offer a terse response. 1. What is the difference between the highest and the second highest Primary completion rate (% of total enrollments) of Benin?
Your answer should be very brief. 1.13. What is the difference between the highest and the second highest Primary completion rate (% of total enrollments) of Burkina Faso?
Provide a succinct answer. 1.75. What is the difference between the highest and the second highest Primary completion rate (% of total enrollments) in El Salvador?
Provide a short and direct response. 2.28. What is the difference between the highest and the second highest Primary completion rate (% of total enrollments) of Netherlands?
Your answer should be very brief. 0.33. What is the difference between the highest and the lowest Primary completion rate (% of total enrollments) in Benin?
Ensure brevity in your answer.  12.44. What is the difference between the highest and the lowest Primary completion rate (% of total enrollments) in Burkina Faso?
Your answer should be compact. 18.36. What is the difference between the highest and the lowest Primary completion rate (% of total enrollments) of El Salvador?
Provide a short and direct response. 41.06. What is the difference between the highest and the lowest Primary completion rate (% of total enrollments) in Netherlands?
Offer a very short reply. 7.05. 